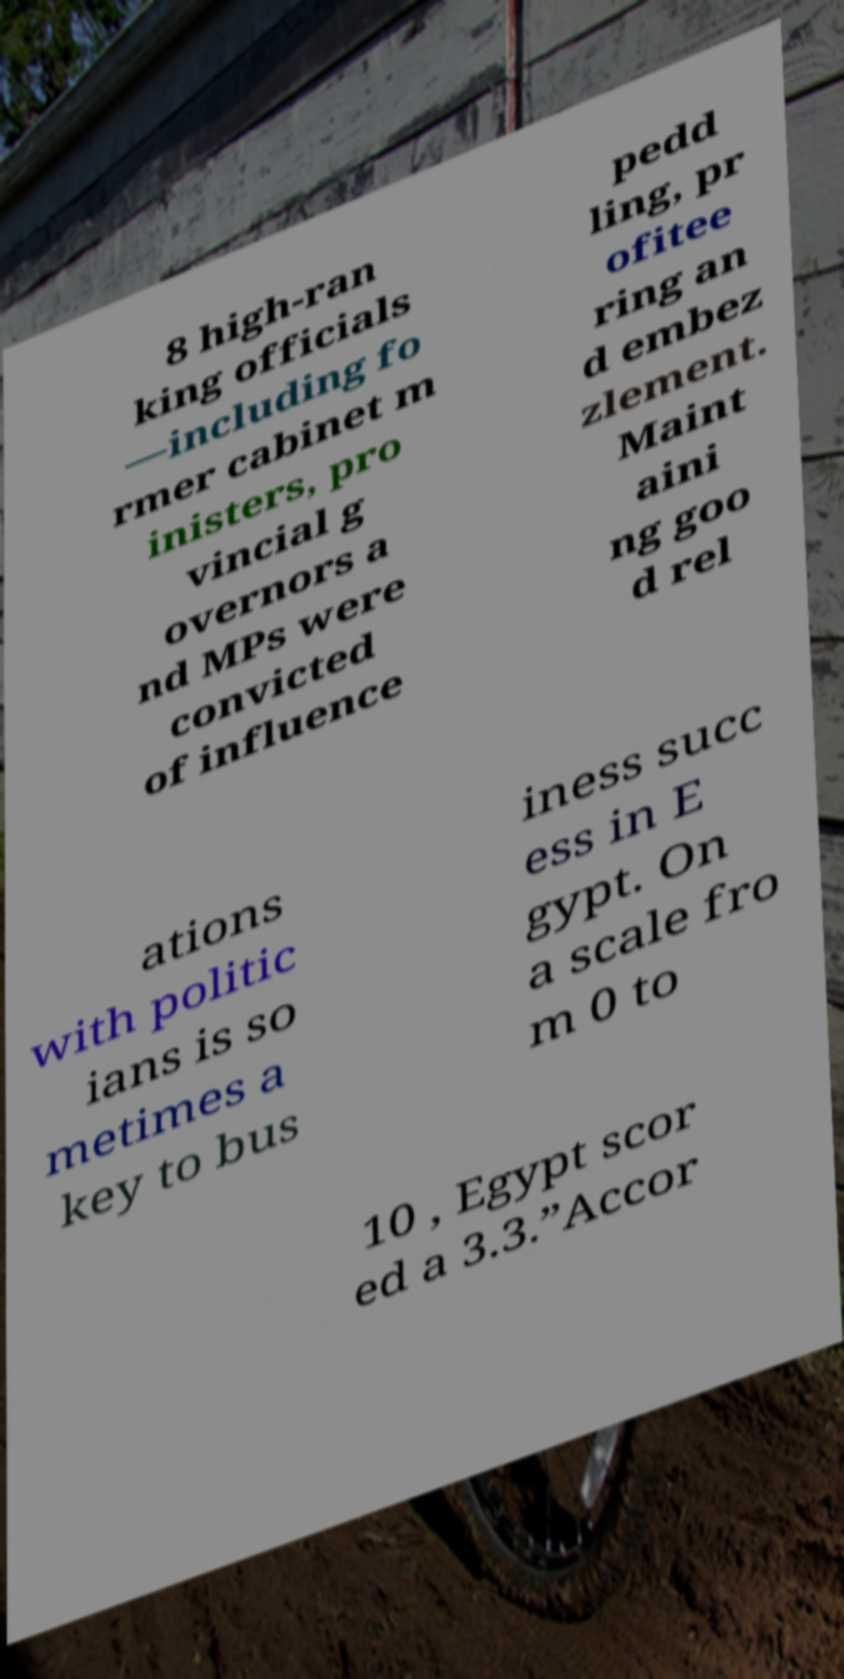For documentation purposes, I need the text within this image transcribed. Could you provide that? 8 high-ran king officials —including fo rmer cabinet m inisters, pro vincial g overnors a nd MPs were convicted of influence pedd ling, pr ofitee ring an d embez zlement. Maint aini ng goo d rel ations with politic ians is so metimes a key to bus iness succ ess in E gypt. On a scale fro m 0 to 10 , Egypt scor ed a 3.3.”Accor 